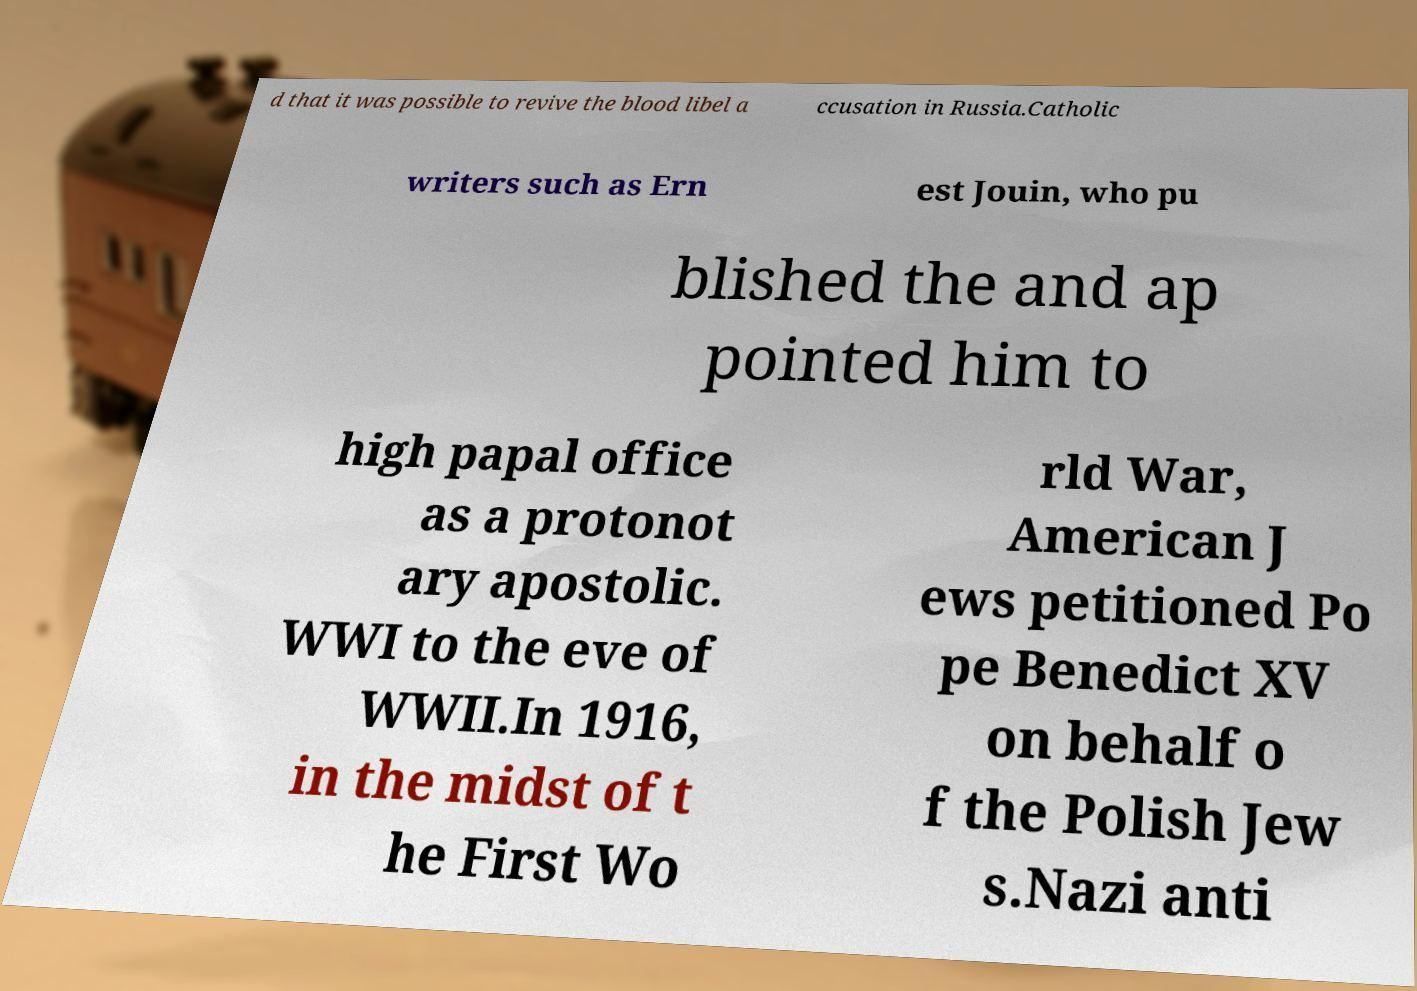Can you accurately transcribe the text from the provided image for me? d that it was possible to revive the blood libel a ccusation in Russia.Catholic writers such as Ern est Jouin, who pu blished the and ap pointed him to high papal office as a protonot ary apostolic. WWI to the eve of WWII.In 1916, in the midst of t he First Wo rld War, American J ews petitioned Po pe Benedict XV on behalf o f the Polish Jew s.Nazi anti 